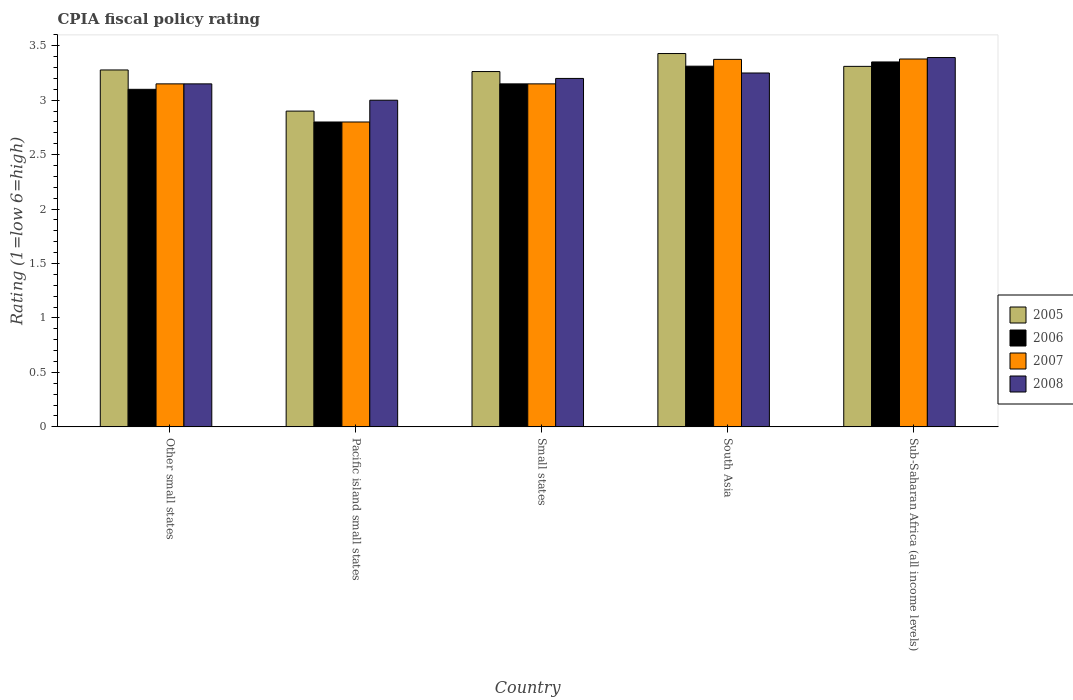How many groups of bars are there?
Your response must be concise. 5. What is the label of the 2nd group of bars from the left?
Offer a very short reply. Pacific island small states. What is the CPIA rating in 2006 in Small states?
Give a very brief answer. 3.15. Across all countries, what is the maximum CPIA rating in 2008?
Provide a succinct answer. 3.39. In which country was the CPIA rating in 2006 maximum?
Provide a succinct answer. Sub-Saharan Africa (all income levels). In which country was the CPIA rating in 2008 minimum?
Your answer should be compact. Pacific island small states. What is the total CPIA rating in 2007 in the graph?
Provide a short and direct response. 15.85. What is the difference between the CPIA rating in 2006 in Small states and that in South Asia?
Your response must be concise. -0.16. What is the difference between the CPIA rating in 2006 in South Asia and the CPIA rating in 2007 in Small states?
Offer a very short reply. 0.16. What is the average CPIA rating in 2005 per country?
Provide a short and direct response. 3.24. What is the difference between the CPIA rating of/in 2005 and CPIA rating of/in 2008 in South Asia?
Keep it short and to the point. 0.18. What is the ratio of the CPIA rating in 2005 in Other small states to that in Sub-Saharan Africa (all income levels)?
Your response must be concise. 0.99. What is the difference between the highest and the second highest CPIA rating in 2006?
Make the answer very short. -0.04. What is the difference between the highest and the lowest CPIA rating in 2005?
Provide a succinct answer. 0.53. Is the sum of the CPIA rating in 2006 in Pacific island small states and Small states greater than the maximum CPIA rating in 2005 across all countries?
Keep it short and to the point. Yes. What does the 4th bar from the left in South Asia represents?
Your answer should be compact. 2008. Are the values on the major ticks of Y-axis written in scientific E-notation?
Your response must be concise. No. Where does the legend appear in the graph?
Your answer should be compact. Center right. What is the title of the graph?
Your response must be concise. CPIA fiscal policy rating. What is the label or title of the X-axis?
Your response must be concise. Country. What is the label or title of the Y-axis?
Give a very brief answer. Rating (1=low 6=high). What is the Rating (1=low 6=high) of 2005 in Other small states?
Keep it short and to the point. 3.28. What is the Rating (1=low 6=high) of 2007 in Other small states?
Give a very brief answer. 3.15. What is the Rating (1=low 6=high) in 2008 in Other small states?
Provide a short and direct response. 3.15. What is the Rating (1=low 6=high) in 2005 in Pacific island small states?
Give a very brief answer. 2.9. What is the Rating (1=low 6=high) in 2008 in Pacific island small states?
Keep it short and to the point. 3. What is the Rating (1=low 6=high) in 2005 in Small states?
Keep it short and to the point. 3.26. What is the Rating (1=low 6=high) in 2006 in Small states?
Keep it short and to the point. 3.15. What is the Rating (1=low 6=high) of 2007 in Small states?
Provide a succinct answer. 3.15. What is the Rating (1=low 6=high) in 2008 in Small states?
Keep it short and to the point. 3.2. What is the Rating (1=low 6=high) in 2005 in South Asia?
Provide a succinct answer. 3.43. What is the Rating (1=low 6=high) of 2006 in South Asia?
Ensure brevity in your answer.  3.31. What is the Rating (1=low 6=high) in 2007 in South Asia?
Ensure brevity in your answer.  3.38. What is the Rating (1=low 6=high) in 2005 in Sub-Saharan Africa (all income levels)?
Offer a terse response. 3.31. What is the Rating (1=low 6=high) in 2006 in Sub-Saharan Africa (all income levels)?
Ensure brevity in your answer.  3.35. What is the Rating (1=low 6=high) of 2007 in Sub-Saharan Africa (all income levels)?
Offer a very short reply. 3.38. What is the Rating (1=low 6=high) in 2008 in Sub-Saharan Africa (all income levels)?
Offer a very short reply. 3.39. Across all countries, what is the maximum Rating (1=low 6=high) of 2005?
Provide a succinct answer. 3.43. Across all countries, what is the maximum Rating (1=low 6=high) in 2006?
Provide a short and direct response. 3.35. Across all countries, what is the maximum Rating (1=low 6=high) in 2007?
Provide a succinct answer. 3.38. Across all countries, what is the maximum Rating (1=low 6=high) of 2008?
Your answer should be compact. 3.39. Across all countries, what is the minimum Rating (1=low 6=high) in 2005?
Your response must be concise. 2.9. Across all countries, what is the minimum Rating (1=low 6=high) of 2007?
Ensure brevity in your answer.  2.8. What is the total Rating (1=low 6=high) of 2005 in the graph?
Your answer should be compact. 16.18. What is the total Rating (1=low 6=high) of 2006 in the graph?
Offer a terse response. 15.71. What is the total Rating (1=low 6=high) in 2007 in the graph?
Your answer should be compact. 15.85. What is the total Rating (1=low 6=high) in 2008 in the graph?
Keep it short and to the point. 15.99. What is the difference between the Rating (1=low 6=high) of 2005 in Other small states and that in Pacific island small states?
Ensure brevity in your answer.  0.38. What is the difference between the Rating (1=low 6=high) in 2006 in Other small states and that in Pacific island small states?
Offer a very short reply. 0.3. What is the difference between the Rating (1=low 6=high) in 2005 in Other small states and that in Small states?
Offer a very short reply. 0.01. What is the difference between the Rating (1=low 6=high) of 2008 in Other small states and that in Small states?
Provide a succinct answer. -0.05. What is the difference between the Rating (1=low 6=high) in 2005 in Other small states and that in South Asia?
Offer a very short reply. -0.15. What is the difference between the Rating (1=low 6=high) of 2006 in Other small states and that in South Asia?
Keep it short and to the point. -0.21. What is the difference between the Rating (1=low 6=high) in 2007 in Other small states and that in South Asia?
Offer a very short reply. -0.23. What is the difference between the Rating (1=low 6=high) of 2005 in Other small states and that in Sub-Saharan Africa (all income levels)?
Provide a succinct answer. -0.03. What is the difference between the Rating (1=low 6=high) of 2006 in Other small states and that in Sub-Saharan Africa (all income levels)?
Your answer should be compact. -0.25. What is the difference between the Rating (1=low 6=high) of 2007 in Other small states and that in Sub-Saharan Africa (all income levels)?
Give a very brief answer. -0.23. What is the difference between the Rating (1=low 6=high) in 2008 in Other small states and that in Sub-Saharan Africa (all income levels)?
Your response must be concise. -0.24. What is the difference between the Rating (1=low 6=high) in 2005 in Pacific island small states and that in Small states?
Keep it short and to the point. -0.36. What is the difference between the Rating (1=low 6=high) in 2006 in Pacific island small states and that in Small states?
Your response must be concise. -0.35. What is the difference between the Rating (1=low 6=high) of 2007 in Pacific island small states and that in Small states?
Your answer should be very brief. -0.35. What is the difference between the Rating (1=low 6=high) of 2005 in Pacific island small states and that in South Asia?
Give a very brief answer. -0.53. What is the difference between the Rating (1=low 6=high) in 2006 in Pacific island small states and that in South Asia?
Your answer should be compact. -0.51. What is the difference between the Rating (1=low 6=high) in 2007 in Pacific island small states and that in South Asia?
Provide a short and direct response. -0.57. What is the difference between the Rating (1=low 6=high) of 2005 in Pacific island small states and that in Sub-Saharan Africa (all income levels)?
Make the answer very short. -0.41. What is the difference between the Rating (1=low 6=high) of 2006 in Pacific island small states and that in Sub-Saharan Africa (all income levels)?
Your response must be concise. -0.55. What is the difference between the Rating (1=low 6=high) of 2007 in Pacific island small states and that in Sub-Saharan Africa (all income levels)?
Keep it short and to the point. -0.58. What is the difference between the Rating (1=low 6=high) of 2008 in Pacific island small states and that in Sub-Saharan Africa (all income levels)?
Your answer should be compact. -0.39. What is the difference between the Rating (1=low 6=high) in 2005 in Small states and that in South Asia?
Your response must be concise. -0.17. What is the difference between the Rating (1=low 6=high) of 2006 in Small states and that in South Asia?
Your answer should be compact. -0.16. What is the difference between the Rating (1=low 6=high) in 2007 in Small states and that in South Asia?
Keep it short and to the point. -0.23. What is the difference between the Rating (1=low 6=high) in 2005 in Small states and that in Sub-Saharan Africa (all income levels)?
Ensure brevity in your answer.  -0.05. What is the difference between the Rating (1=low 6=high) of 2006 in Small states and that in Sub-Saharan Africa (all income levels)?
Make the answer very short. -0.2. What is the difference between the Rating (1=low 6=high) in 2007 in Small states and that in Sub-Saharan Africa (all income levels)?
Offer a very short reply. -0.23. What is the difference between the Rating (1=low 6=high) in 2008 in Small states and that in Sub-Saharan Africa (all income levels)?
Keep it short and to the point. -0.19. What is the difference between the Rating (1=low 6=high) in 2005 in South Asia and that in Sub-Saharan Africa (all income levels)?
Ensure brevity in your answer.  0.12. What is the difference between the Rating (1=low 6=high) of 2006 in South Asia and that in Sub-Saharan Africa (all income levels)?
Provide a succinct answer. -0.04. What is the difference between the Rating (1=low 6=high) in 2007 in South Asia and that in Sub-Saharan Africa (all income levels)?
Keep it short and to the point. -0. What is the difference between the Rating (1=low 6=high) of 2008 in South Asia and that in Sub-Saharan Africa (all income levels)?
Provide a short and direct response. -0.14. What is the difference between the Rating (1=low 6=high) in 2005 in Other small states and the Rating (1=low 6=high) in 2006 in Pacific island small states?
Your answer should be compact. 0.48. What is the difference between the Rating (1=low 6=high) of 2005 in Other small states and the Rating (1=low 6=high) of 2007 in Pacific island small states?
Ensure brevity in your answer.  0.48. What is the difference between the Rating (1=low 6=high) of 2005 in Other small states and the Rating (1=low 6=high) of 2008 in Pacific island small states?
Offer a terse response. 0.28. What is the difference between the Rating (1=low 6=high) of 2005 in Other small states and the Rating (1=low 6=high) of 2006 in Small states?
Provide a succinct answer. 0.13. What is the difference between the Rating (1=low 6=high) in 2005 in Other small states and the Rating (1=low 6=high) in 2007 in Small states?
Provide a short and direct response. 0.13. What is the difference between the Rating (1=low 6=high) of 2005 in Other small states and the Rating (1=low 6=high) of 2008 in Small states?
Ensure brevity in your answer.  0.08. What is the difference between the Rating (1=low 6=high) in 2006 in Other small states and the Rating (1=low 6=high) in 2007 in Small states?
Give a very brief answer. -0.05. What is the difference between the Rating (1=low 6=high) in 2007 in Other small states and the Rating (1=low 6=high) in 2008 in Small states?
Keep it short and to the point. -0.05. What is the difference between the Rating (1=low 6=high) in 2005 in Other small states and the Rating (1=low 6=high) in 2006 in South Asia?
Your answer should be compact. -0.03. What is the difference between the Rating (1=low 6=high) in 2005 in Other small states and the Rating (1=low 6=high) in 2007 in South Asia?
Keep it short and to the point. -0.1. What is the difference between the Rating (1=low 6=high) of 2005 in Other small states and the Rating (1=low 6=high) of 2008 in South Asia?
Make the answer very short. 0.03. What is the difference between the Rating (1=low 6=high) of 2006 in Other small states and the Rating (1=low 6=high) of 2007 in South Asia?
Offer a terse response. -0.28. What is the difference between the Rating (1=low 6=high) of 2005 in Other small states and the Rating (1=low 6=high) of 2006 in Sub-Saharan Africa (all income levels)?
Make the answer very short. -0.07. What is the difference between the Rating (1=low 6=high) in 2005 in Other small states and the Rating (1=low 6=high) in 2007 in Sub-Saharan Africa (all income levels)?
Provide a succinct answer. -0.1. What is the difference between the Rating (1=low 6=high) of 2005 in Other small states and the Rating (1=low 6=high) of 2008 in Sub-Saharan Africa (all income levels)?
Give a very brief answer. -0.11. What is the difference between the Rating (1=low 6=high) in 2006 in Other small states and the Rating (1=low 6=high) in 2007 in Sub-Saharan Africa (all income levels)?
Your answer should be compact. -0.28. What is the difference between the Rating (1=low 6=high) in 2006 in Other small states and the Rating (1=low 6=high) in 2008 in Sub-Saharan Africa (all income levels)?
Ensure brevity in your answer.  -0.29. What is the difference between the Rating (1=low 6=high) of 2007 in Other small states and the Rating (1=low 6=high) of 2008 in Sub-Saharan Africa (all income levels)?
Ensure brevity in your answer.  -0.24. What is the difference between the Rating (1=low 6=high) of 2005 in Pacific island small states and the Rating (1=low 6=high) of 2007 in Small states?
Give a very brief answer. -0.25. What is the difference between the Rating (1=low 6=high) in 2006 in Pacific island small states and the Rating (1=low 6=high) in 2007 in Small states?
Provide a short and direct response. -0.35. What is the difference between the Rating (1=low 6=high) of 2007 in Pacific island small states and the Rating (1=low 6=high) of 2008 in Small states?
Your answer should be very brief. -0.4. What is the difference between the Rating (1=low 6=high) of 2005 in Pacific island small states and the Rating (1=low 6=high) of 2006 in South Asia?
Offer a very short reply. -0.41. What is the difference between the Rating (1=low 6=high) of 2005 in Pacific island small states and the Rating (1=low 6=high) of 2007 in South Asia?
Give a very brief answer. -0.47. What is the difference between the Rating (1=low 6=high) of 2005 in Pacific island small states and the Rating (1=low 6=high) of 2008 in South Asia?
Your response must be concise. -0.35. What is the difference between the Rating (1=low 6=high) in 2006 in Pacific island small states and the Rating (1=low 6=high) in 2007 in South Asia?
Offer a terse response. -0.57. What is the difference between the Rating (1=low 6=high) in 2006 in Pacific island small states and the Rating (1=low 6=high) in 2008 in South Asia?
Your response must be concise. -0.45. What is the difference between the Rating (1=low 6=high) of 2007 in Pacific island small states and the Rating (1=low 6=high) of 2008 in South Asia?
Your response must be concise. -0.45. What is the difference between the Rating (1=low 6=high) in 2005 in Pacific island small states and the Rating (1=low 6=high) in 2006 in Sub-Saharan Africa (all income levels)?
Offer a terse response. -0.45. What is the difference between the Rating (1=low 6=high) of 2005 in Pacific island small states and the Rating (1=low 6=high) of 2007 in Sub-Saharan Africa (all income levels)?
Offer a very short reply. -0.48. What is the difference between the Rating (1=low 6=high) of 2005 in Pacific island small states and the Rating (1=low 6=high) of 2008 in Sub-Saharan Africa (all income levels)?
Your answer should be compact. -0.49. What is the difference between the Rating (1=low 6=high) in 2006 in Pacific island small states and the Rating (1=low 6=high) in 2007 in Sub-Saharan Africa (all income levels)?
Make the answer very short. -0.58. What is the difference between the Rating (1=low 6=high) of 2006 in Pacific island small states and the Rating (1=low 6=high) of 2008 in Sub-Saharan Africa (all income levels)?
Ensure brevity in your answer.  -0.59. What is the difference between the Rating (1=low 6=high) of 2007 in Pacific island small states and the Rating (1=low 6=high) of 2008 in Sub-Saharan Africa (all income levels)?
Ensure brevity in your answer.  -0.59. What is the difference between the Rating (1=low 6=high) in 2005 in Small states and the Rating (1=low 6=high) in 2006 in South Asia?
Provide a succinct answer. -0.05. What is the difference between the Rating (1=low 6=high) in 2005 in Small states and the Rating (1=low 6=high) in 2007 in South Asia?
Give a very brief answer. -0.11. What is the difference between the Rating (1=low 6=high) of 2005 in Small states and the Rating (1=low 6=high) of 2008 in South Asia?
Ensure brevity in your answer.  0.01. What is the difference between the Rating (1=low 6=high) of 2006 in Small states and the Rating (1=low 6=high) of 2007 in South Asia?
Offer a terse response. -0.23. What is the difference between the Rating (1=low 6=high) in 2006 in Small states and the Rating (1=low 6=high) in 2008 in South Asia?
Keep it short and to the point. -0.1. What is the difference between the Rating (1=low 6=high) in 2005 in Small states and the Rating (1=low 6=high) in 2006 in Sub-Saharan Africa (all income levels)?
Offer a terse response. -0.09. What is the difference between the Rating (1=low 6=high) in 2005 in Small states and the Rating (1=low 6=high) in 2007 in Sub-Saharan Africa (all income levels)?
Your answer should be very brief. -0.12. What is the difference between the Rating (1=low 6=high) of 2005 in Small states and the Rating (1=low 6=high) of 2008 in Sub-Saharan Africa (all income levels)?
Keep it short and to the point. -0.13. What is the difference between the Rating (1=low 6=high) in 2006 in Small states and the Rating (1=low 6=high) in 2007 in Sub-Saharan Africa (all income levels)?
Offer a very short reply. -0.23. What is the difference between the Rating (1=low 6=high) of 2006 in Small states and the Rating (1=low 6=high) of 2008 in Sub-Saharan Africa (all income levels)?
Offer a terse response. -0.24. What is the difference between the Rating (1=low 6=high) of 2007 in Small states and the Rating (1=low 6=high) of 2008 in Sub-Saharan Africa (all income levels)?
Your answer should be very brief. -0.24. What is the difference between the Rating (1=low 6=high) in 2005 in South Asia and the Rating (1=low 6=high) in 2006 in Sub-Saharan Africa (all income levels)?
Give a very brief answer. 0.08. What is the difference between the Rating (1=low 6=high) of 2005 in South Asia and the Rating (1=low 6=high) of 2007 in Sub-Saharan Africa (all income levels)?
Give a very brief answer. 0.05. What is the difference between the Rating (1=low 6=high) in 2005 in South Asia and the Rating (1=low 6=high) in 2008 in Sub-Saharan Africa (all income levels)?
Offer a very short reply. 0.04. What is the difference between the Rating (1=low 6=high) of 2006 in South Asia and the Rating (1=low 6=high) of 2007 in Sub-Saharan Africa (all income levels)?
Provide a short and direct response. -0.07. What is the difference between the Rating (1=low 6=high) of 2006 in South Asia and the Rating (1=low 6=high) of 2008 in Sub-Saharan Africa (all income levels)?
Keep it short and to the point. -0.08. What is the difference between the Rating (1=low 6=high) of 2007 in South Asia and the Rating (1=low 6=high) of 2008 in Sub-Saharan Africa (all income levels)?
Provide a short and direct response. -0.02. What is the average Rating (1=low 6=high) of 2005 per country?
Ensure brevity in your answer.  3.24. What is the average Rating (1=low 6=high) in 2006 per country?
Offer a terse response. 3.14. What is the average Rating (1=low 6=high) in 2007 per country?
Provide a short and direct response. 3.17. What is the average Rating (1=low 6=high) of 2008 per country?
Offer a very short reply. 3.2. What is the difference between the Rating (1=low 6=high) in 2005 and Rating (1=low 6=high) in 2006 in Other small states?
Your answer should be compact. 0.18. What is the difference between the Rating (1=low 6=high) of 2005 and Rating (1=low 6=high) of 2007 in Other small states?
Ensure brevity in your answer.  0.13. What is the difference between the Rating (1=low 6=high) of 2005 and Rating (1=low 6=high) of 2008 in Other small states?
Make the answer very short. 0.13. What is the difference between the Rating (1=low 6=high) of 2007 and Rating (1=low 6=high) of 2008 in Other small states?
Ensure brevity in your answer.  0. What is the difference between the Rating (1=low 6=high) of 2005 and Rating (1=low 6=high) of 2006 in Pacific island small states?
Give a very brief answer. 0.1. What is the difference between the Rating (1=low 6=high) in 2005 and Rating (1=low 6=high) in 2007 in Pacific island small states?
Ensure brevity in your answer.  0.1. What is the difference between the Rating (1=low 6=high) of 2007 and Rating (1=low 6=high) of 2008 in Pacific island small states?
Ensure brevity in your answer.  -0.2. What is the difference between the Rating (1=low 6=high) of 2005 and Rating (1=low 6=high) of 2006 in Small states?
Keep it short and to the point. 0.11. What is the difference between the Rating (1=low 6=high) in 2005 and Rating (1=low 6=high) in 2007 in Small states?
Provide a succinct answer. 0.11. What is the difference between the Rating (1=low 6=high) in 2005 and Rating (1=low 6=high) in 2008 in Small states?
Offer a very short reply. 0.06. What is the difference between the Rating (1=low 6=high) in 2006 and Rating (1=low 6=high) in 2007 in Small states?
Offer a very short reply. 0. What is the difference between the Rating (1=low 6=high) in 2007 and Rating (1=low 6=high) in 2008 in Small states?
Make the answer very short. -0.05. What is the difference between the Rating (1=low 6=high) of 2005 and Rating (1=low 6=high) of 2006 in South Asia?
Your response must be concise. 0.12. What is the difference between the Rating (1=low 6=high) in 2005 and Rating (1=low 6=high) in 2007 in South Asia?
Keep it short and to the point. 0.05. What is the difference between the Rating (1=low 6=high) of 2005 and Rating (1=low 6=high) of 2008 in South Asia?
Your answer should be very brief. 0.18. What is the difference between the Rating (1=low 6=high) in 2006 and Rating (1=low 6=high) in 2007 in South Asia?
Provide a short and direct response. -0.06. What is the difference between the Rating (1=low 6=high) of 2006 and Rating (1=low 6=high) of 2008 in South Asia?
Make the answer very short. 0.06. What is the difference between the Rating (1=low 6=high) in 2007 and Rating (1=low 6=high) in 2008 in South Asia?
Provide a short and direct response. 0.12. What is the difference between the Rating (1=low 6=high) of 2005 and Rating (1=low 6=high) of 2006 in Sub-Saharan Africa (all income levels)?
Offer a terse response. -0.04. What is the difference between the Rating (1=low 6=high) of 2005 and Rating (1=low 6=high) of 2007 in Sub-Saharan Africa (all income levels)?
Your response must be concise. -0.07. What is the difference between the Rating (1=low 6=high) in 2005 and Rating (1=low 6=high) in 2008 in Sub-Saharan Africa (all income levels)?
Offer a very short reply. -0.08. What is the difference between the Rating (1=low 6=high) of 2006 and Rating (1=low 6=high) of 2007 in Sub-Saharan Africa (all income levels)?
Keep it short and to the point. -0.03. What is the difference between the Rating (1=low 6=high) of 2006 and Rating (1=low 6=high) of 2008 in Sub-Saharan Africa (all income levels)?
Your answer should be compact. -0.04. What is the difference between the Rating (1=low 6=high) in 2007 and Rating (1=low 6=high) in 2008 in Sub-Saharan Africa (all income levels)?
Provide a succinct answer. -0.01. What is the ratio of the Rating (1=low 6=high) of 2005 in Other small states to that in Pacific island small states?
Provide a short and direct response. 1.13. What is the ratio of the Rating (1=low 6=high) of 2006 in Other small states to that in Pacific island small states?
Your answer should be very brief. 1.11. What is the ratio of the Rating (1=low 6=high) of 2006 in Other small states to that in Small states?
Offer a terse response. 0.98. What is the ratio of the Rating (1=low 6=high) in 2007 in Other small states to that in Small states?
Provide a short and direct response. 1. What is the ratio of the Rating (1=low 6=high) of 2008 in Other small states to that in Small states?
Offer a terse response. 0.98. What is the ratio of the Rating (1=low 6=high) in 2005 in Other small states to that in South Asia?
Offer a terse response. 0.96. What is the ratio of the Rating (1=low 6=high) in 2006 in Other small states to that in South Asia?
Provide a succinct answer. 0.94. What is the ratio of the Rating (1=low 6=high) in 2007 in Other small states to that in South Asia?
Give a very brief answer. 0.93. What is the ratio of the Rating (1=low 6=high) in 2008 in Other small states to that in South Asia?
Your answer should be compact. 0.97. What is the ratio of the Rating (1=low 6=high) of 2006 in Other small states to that in Sub-Saharan Africa (all income levels)?
Ensure brevity in your answer.  0.93. What is the ratio of the Rating (1=low 6=high) in 2007 in Other small states to that in Sub-Saharan Africa (all income levels)?
Your response must be concise. 0.93. What is the ratio of the Rating (1=low 6=high) of 2008 in Other small states to that in Sub-Saharan Africa (all income levels)?
Your answer should be very brief. 0.93. What is the ratio of the Rating (1=low 6=high) of 2005 in Pacific island small states to that in Small states?
Provide a short and direct response. 0.89. What is the ratio of the Rating (1=low 6=high) in 2006 in Pacific island small states to that in Small states?
Your answer should be compact. 0.89. What is the ratio of the Rating (1=low 6=high) in 2008 in Pacific island small states to that in Small states?
Provide a succinct answer. 0.94. What is the ratio of the Rating (1=low 6=high) in 2005 in Pacific island small states to that in South Asia?
Ensure brevity in your answer.  0.85. What is the ratio of the Rating (1=low 6=high) in 2006 in Pacific island small states to that in South Asia?
Ensure brevity in your answer.  0.85. What is the ratio of the Rating (1=low 6=high) in 2007 in Pacific island small states to that in South Asia?
Keep it short and to the point. 0.83. What is the ratio of the Rating (1=low 6=high) in 2008 in Pacific island small states to that in South Asia?
Ensure brevity in your answer.  0.92. What is the ratio of the Rating (1=low 6=high) of 2005 in Pacific island small states to that in Sub-Saharan Africa (all income levels)?
Your answer should be very brief. 0.88. What is the ratio of the Rating (1=low 6=high) of 2006 in Pacific island small states to that in Sub-Saharan Africa (all income levels)?
Provide a succinct answer. 0.84. What is the ratio of the Rating (1=low 6=high) in 2007 in Pacific island small states to that in Sub-Saharan Africa (all income levels)?
Your response must be concise. 0.83. What is the ratio of the Rating (1=low 6=high) of 2008 in Pacific island small states to that in Sub-Saharan Africa (all income levels)?
Your answer should be compact. 0.88. What is the ratio of the Rating (1=low 6=high) of 2005 in Small states to that in South Asia?
Make the answer very short. 0.95. What is the ratio of the Rating (1=low 6=high) of 2006 in Small states to that in South Asia?
Your response must be concise. 0.95. What is the ratio of the Rating (1=low 6=high) of 2007 in Small states to that in South Asia?
Provide a short and direct response. 0.93. What is the ratio of the Rating (1=low 6=high) of 2008 in Small states to that in South Asia?
Ensure brevity in your answer.  0.98. What is the ratio of the Rating (1=low 6=high) of 2005 in Small states to that in Sub-Saharan Africa (all income levels)?
Your answer should be very brief. 0.99. What is the ratio of the Rating (1=low 6=high) in 2006 in Small states to that in Sub-Saharan Africa (all income levels)?
Your answer should be very brief. 0.94. What is the ratio of the Rating (1=low 6=high) of 2007 in Small states to that in Sub-Saharan Africa (all income levels)?
Ensure brevity in your answer.  0.93. What is the ratio of the Rating (1=low 6=high) of 2008 in Small states to that in Sub-Saharan Africa (all income levels)?
Make the answer very short. 0.94. What is the ratio of the Rating (1=low 6=high) of 2005 in South Asia to that in Sub-Saharan Africa (all income levels)?
Your answer should be very brief. 1.04. What is the ratio of the Rating (1=low 6=high) in 2006 in South Asia to that in Sub-Saharan Africa (all income levels)?
Provide a short and direct response. 0.99. What is the ratio of the Rating (1=low 6=high) of 2007 in South Asia to that in Sub-Saharan Africa (all income levels)?
Keep it short and to the point. 1. What is the ratio of the Rating (1=low 6=high) of 2008 in South Asia to that in Sub-Saharan Africa (all income levels)?
Your answer should be very brief. 0.96. What is the difference between the highest and the second highest Rating (1=low 6=high) of 2005?
Make the answer very short. 0.12. What is the difference between the highest and the second highest Rating (1=low 6=high) of 2006?
Give a very brief answer. 0.04. What is the difference between the highest and the second highest Rating (1=low 6=high) of 2007?
Give a very brief answer. 0. What is the difference between the highest and the second highest Rating (1=low 6=high) in 2008?
Offer a very short reply. 0.14. What is the difference between the highest and the lowest Rating (1=low 6=high) of 2005?
Offer a very short reply. 0.53. What is the difference between the highest and the lowest Rating (1=low 6=high) in 2006?
Keep it short and to the point. 0.55. What is the difference between the highest and the lowest Rating (1=low 6=high) of 2007?
Make the answer very short. 0.58. What is the difference between the highest and the lowest Rating (1=low 6=high) of 2008?
Offer a terse response. 0.39. 